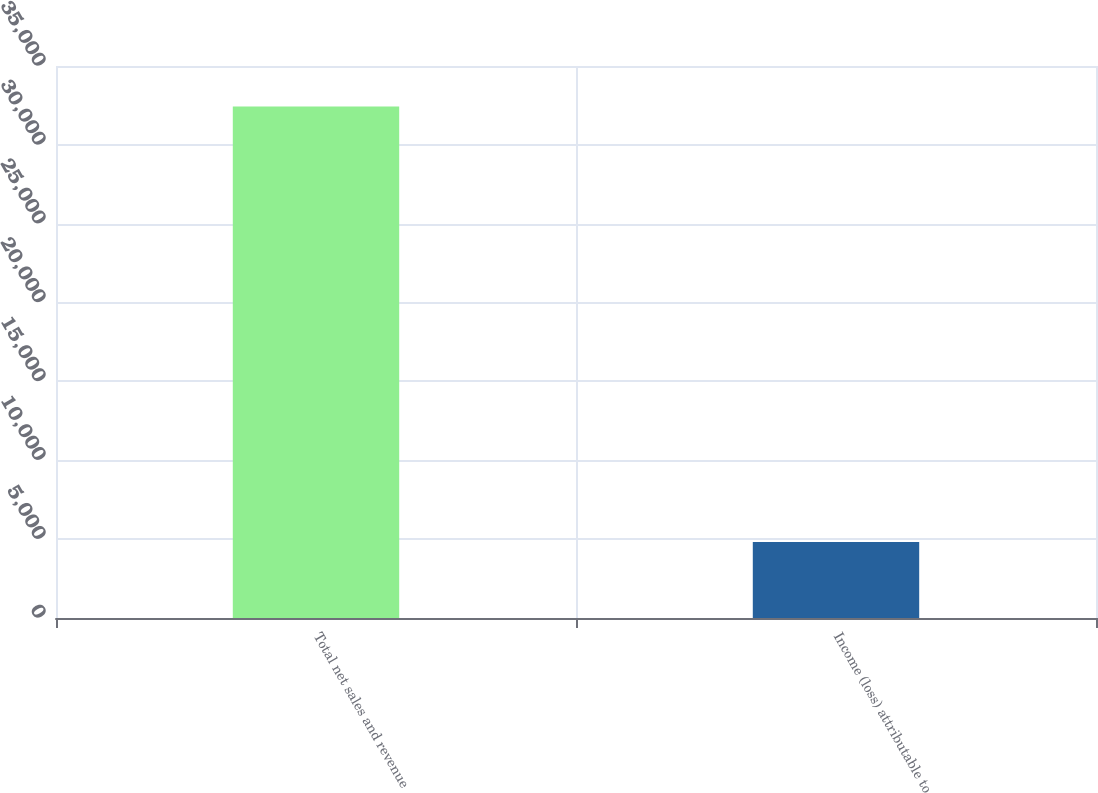Convert chart to OTSL. <chart><loc_0><loc_0><loc_500><loc_500><bar_chart><fcel>Total net sales and revenue<fcel>Income (loss) attributable to<nl><fcel>32426<fcel>4820<nl></chart> 